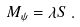Convert formula to latex. <formula><loc_0><loc_0><loc_500><loc_500>M _ { \psi } = \lambda S \, .</formula> 